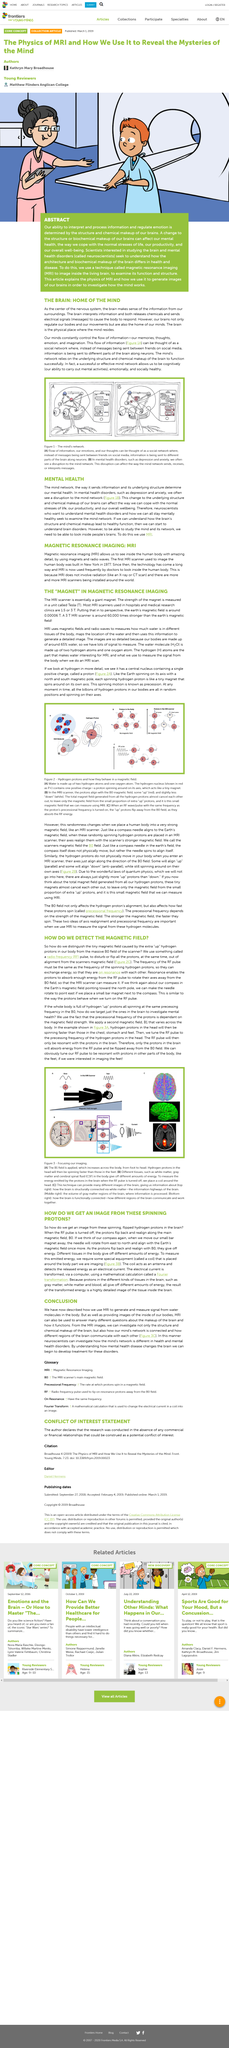Point out several critical features in this image. The process of producing an image of the brain involves applying a B1 field to the body, placing a coil around the head, and tuning the RF pulse to the frequency of hydrogen protons in the brain, causing them to spin faster in the head than in the feet, resulting in an image of the brain. Magnetic Resonance Imaging, commonly referred to as MRI, is a medical imaging technique that uses a powerful magnetic field, radio waves, and a computer to produce detailed images of the organs and tissues within the body. Protons are the central nuclei of hydrogen atoms, and they contain a single positive charge. Specifically, a proton figure 2A is a subatomic particle that is composed of three quarks, two of which are up quarks and one of which is a down quark. These quarks are held together by the strong nuclear force, which is one of the fundamental forces of nature. The proton is an important building block of matter in the universe, and it is an essential component of many chemical reactions and biological processes. Resonance allows protons to absorb enough energy from the RF pulse to rotate their axes away from the BO field, enabling the MRI scanner to measure them. Neuroscientists are scientists who are interested in understanding mental health disorders. 